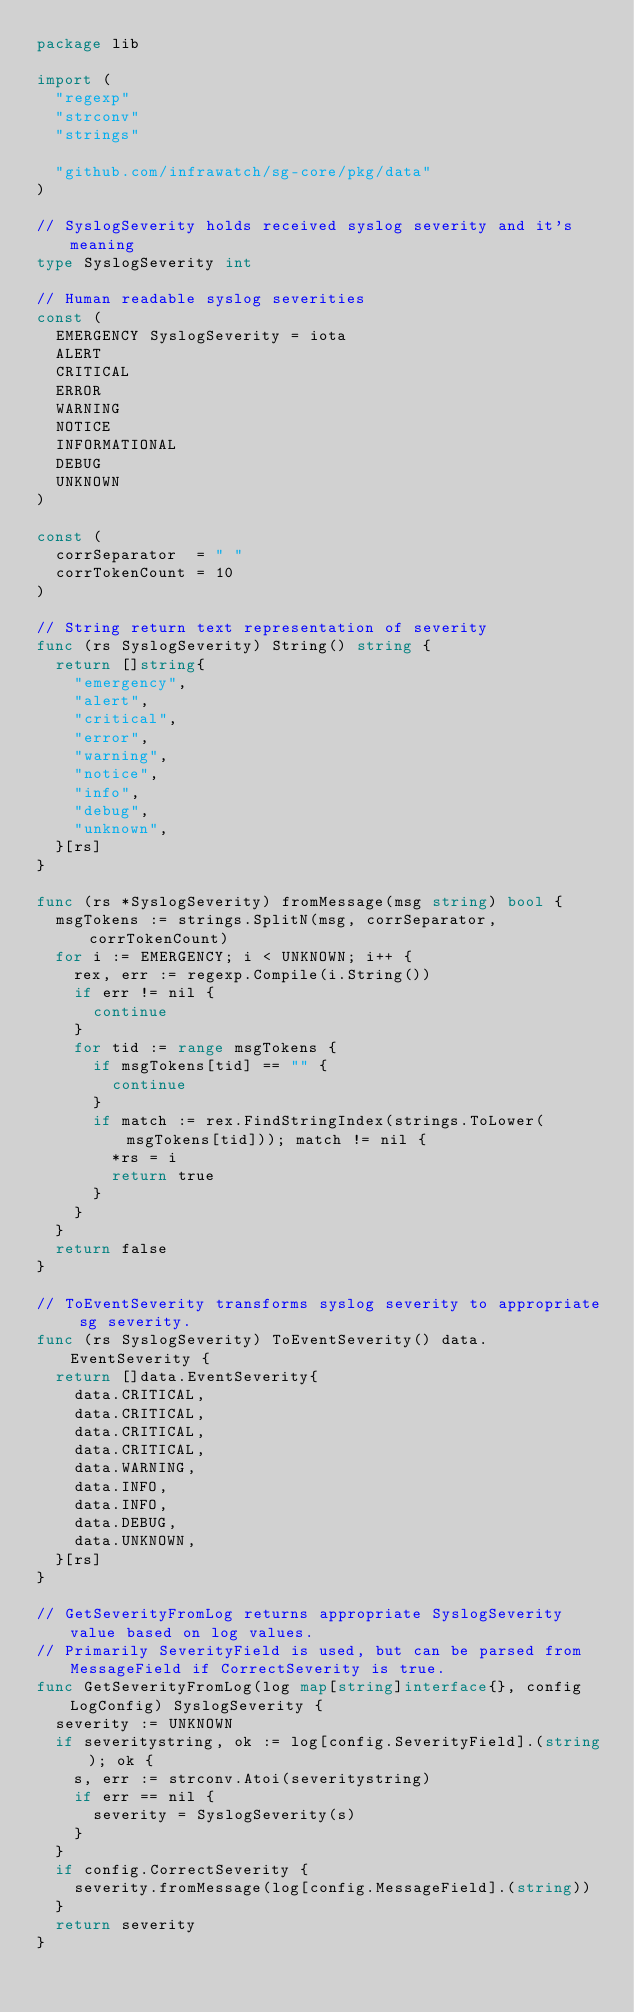Convert code to text. <code><loc_0><loc_0><loc_500><loc_500><_Go_>package lib

import (
	"regexp"
	"strconv"
	"strings"

	"github.com/infrawatch/sg-core/pkg/data"
)

// SyslogSeverity holds received syslog severity and it's meaning
type SyslogSeverity int

// Human readable syslog severities
const (
	EMERGENCY SyslogSeverity = iota
	ALERT
	CRITICAL
	ERROR
	WARNING
	NOTICE
	INFORMATIONAL
	DEBUG
	UNKNOWN
)

const (
	corrSeparator  = " "
	corrTokenCount = 10
)

// String return text representation of severity
func (rs SyslogSeverity) String() string {
	return []string{
		"emergency",
		"alert",
		"critical",
		"error",
		"warning",
		"notice",
		"info",
		"debug",
		"unknown",
	}[rs]
}

func (rs *SyslogSeverity) fromMessage(msg string) bool {
	msgTokens := strings.SplitN(msg, corrSeparator, corrTokenCount)
	for i := EMERGENCY; i < UNKNOWN; i++ {
		rex, err := regexp.Compile(i.String())
		if err != nil {
			continue
		}
		for tid := range msgTokens {
			if msgTokens[tid] == "" {
				continue
			}
			if match := rex.FindStringIndex(strings.ToLower(msgTokens[tid])); match != nil {
				*rs = i
				return true
			}
		}
	}
	return false
}

// ToEventSeverity transforms syslog severity to appropriate sg severity.
func (rs SyslogSeverity) ToEventSeverity() data.EventSeverity {
	return []data.EventSeverity{
		data.CRITICAL,
		data.CRITICAL,
		data.CRITICAL,
		data.CRITICAL,
		data.WARNING,
		data.INFO,
		data.INFO,
		data.DEBUG,
		data.UNKNOWN,
	}[rs]
}

// GetSeverityFromLog returns appropriate SyslogSeverity value based on log values.
// Primarily SeverityField is used, but can be parsed from MessageField if CorrectSeverity is true.
func GetSeverityFromLog(log map[string]interface{}, config LogConfig) SyslogSeverity {
	severity := UNKNOWN
	if severitystring, ok := log[config.SeverityField].(string); ok {
		s, err := strconv.Atoi(severitystring)
		if err == nil {
			severity = SyslogSeverity(s)
		}
	}
	if config.CorrectSeverity {
		severity.fromMessage(log[config.MessageField].(string))
	}
	return severity
}
</code> 